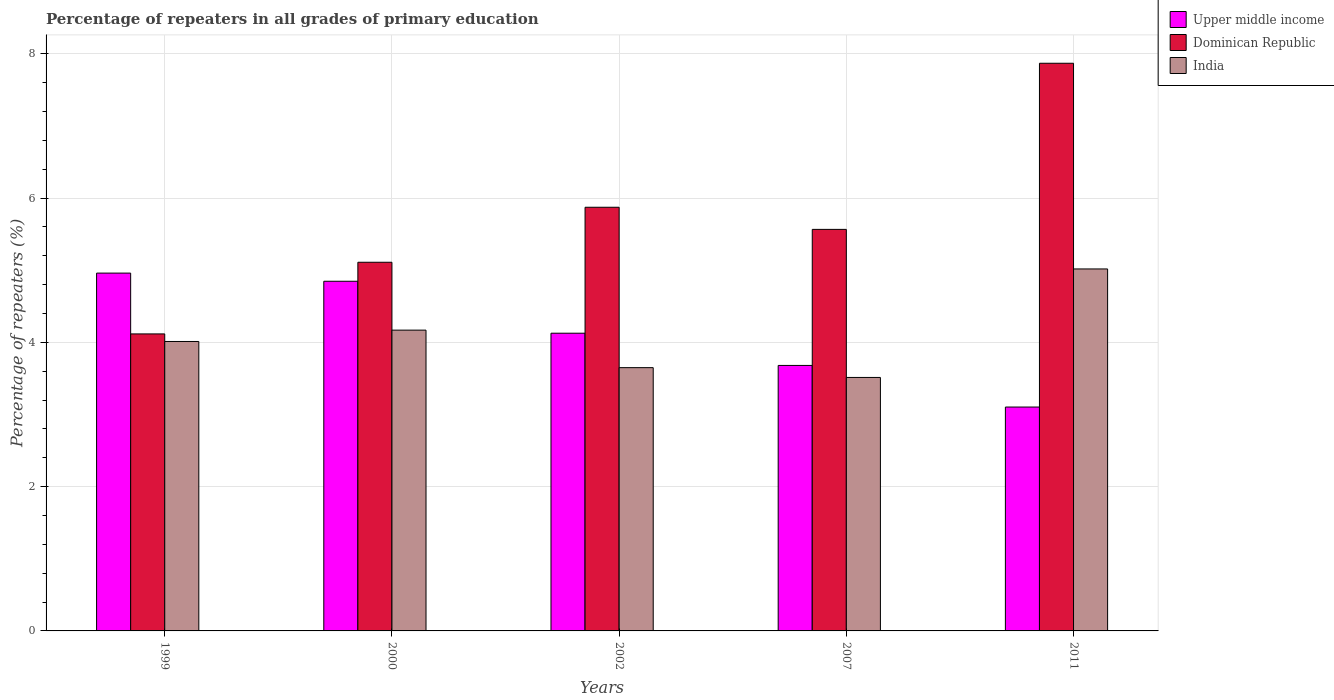How many different coloured bars are there?
Offer a very short reply. 3. Are the number of bars per tick equal to the number of legend labels?
Provide a short and direct response. Yes. How many bars are there on the 1st tick from the left?
Give a very brief answer. 3. How many bars are there on the 4th tick from the right?
Your response must be concise. 3. What is the label of the 3rd group of bars from the left?
Provide a succinct answer. 2002. What is the percentage of repeaters in Dominican Republic in 2011?
Your response must be concise. 7.87. Across all years, what is the maximum percentage of repeaters in India?
Keep it short and to the point. 5.02. Across all years, what is the minimum percentage of repeaters in Dominican Republic?
Your response must be concise. 4.12. What is the total percentage of repeaters in India in the graph?
Provide a short and direct response. 20.36. What is the difference between the percentage of repeaters in Upper middle income in 2000 and that in 2002?
Make the answer very short. 0.72. What is the difference between the percentage of repeaters in Dominican Republic in 2011 and the percentage of repeaters in India in 2007?
Offer a terse response. 4.35. What is the average percentage of repeaters in India per year?
Your response must be concise. 4.07. In the year 2000, what is the difference between the percentage of repeaters in Dominican Republic and percentage of repeaters in Upper middle income?
Ensure brevity in your answer.  0.26. What is the ratio of the percentage of repeaters in Dominican Republic in 2002 to that in 2007?
Provide a short and direct response. 1.06. What is the difference between the highest and the second highest percentage of repeaters in Dominican Republic?
Keep it short and to the point. 2. What is the difference between the highest and the lowest percentage of repeaters in Dominican Republic?
Offer a very short reply. 3.75. In how many years, is the percentage of repeaters in Dominican Republic greater than the average percentage of repeaters in Dominican Republic taken over all years?
Your answer should be compact. 2. Is the sum of the percentage of repeaters in India in 1999 and 2000 greater than the maximum percentage of repeaters in Upper middle income across all years?
Your response must be concise. Yes. What does the 1st bar from the right in 2002 represents?
Give a very brief answer. India. How many years are there in the graph?
Provide a short and direct response. 5. What is the difference between two consecutive major ticks on the Y-axis?
Your response must be concise. 2. Are the values on the major ticks of Y-axis written in scientific E-notation?
Offer a terse response. No. Does the graph contain any zero values?
Ensure brevity in your answer.  No. Where does the legend appear in the graph?
Your response must be concise. Top right. What is the title of the graph?
Offer a very short reply. Percentage of repeaters in all grades of primary education. What is the label or title of the Y-axis?
Offer a very short reply. Percentage of repeaters (%). What is the Percentage of repeaters (%) of Upper middle income in 1999?
Offer a terse response. 4.96. What is the Percentage of repeaters (%) of Dominican Republic in 1999?
Offer a terse response. 4.12. What is the Percentage of repeaters (%) of India in 1999?
Make the answer very short. 4.01. What is the Percentage of repeaters (%) in Upper middle income in 2000?
Your answer should be compact. 4.85. What is the Percentage of repeaters (%) in Dominican Republic in 2000?
Give a very brief answer. 5.11. What is the Percentage of repeaters (%) in India in 2000?
Ensure brevity in your answer.  4.17. What is the Percentage of repeaters (%) of Upper middle income in 2002?
Your response must be concise. 4.13. What is the Percentage of repeaters (%) of Dominican Republic in 2002?
Offer a very short reply. 5.87. What is the Percentage of repeaters (%) in India in 2002?
Your response must be concise. 3.65. What is the Percentage of repeaters (%) in Upper middle income in 2007?
Give a very brief answer. 3.68. What is the Percentage of repeaters (%) of Dominican Republic in 2007?
Your answer should be very brief. 5.57. What is the Percentage of repeaters (%) of India in 2007?
Provide a short and direct response. 3.51. What is the Percentage of repeaters (%) of Upper middle income in 2011?
Give a very brief answer. 3.1. What is the Percentage of repeaters (%) in Dominican Republic in 2011?
Provide a short and direct response. 7.87. What is the Percentage of repeaters (%) in India in 2011?
Offer a terse response. 5.02. Across all years, what is the maximum Percentage of repeaters (%) of Upper middle income?
Offer a terse response. 4.96. Across all years, what is the maximum Percentage of repeaters (%) of Dominican Republic?
Provide a short and direct response. 7.87. Across all years, what is the maximum Percentage of repeaters (%) in India?
Provide a succinct answer. 5.02. Across all years, what is the minimum Percentage of repeaters (%) in Upper middle income?
Your answer should be very brief. 3.1. Across all years, what is the minimum Percentage of repeaters (%) of Dominican Republic?
Your response must be concise. 4.12. Across all years, what is the minimum Percentage of repeaters (%) in India?
Your answer should be very brief. 3.51. What is the total Percentage of repeaters (%) of Upper middle income in the graph?
Your answer should be compact. 20.72. What is the total Percentage of repeaters (%) in Dominican Republic in the graph?
Offer a terse response. 28.53. What is the total Percentage of repeaters (%) of India in the graph?
Offer a very short reply. 20.36. What is the difference between the Percentage of repeaters (%) of Upper middle income in 1999 and that in 2000?
Provide a short and direct response. 0.11. What is the difference between the Percentage of repeaters (%) of Dominican Republic in 1999 and that in 2000?
Ensure brevity in your answer.  -0.99. What is the difference between the Percentage of repeaters (%) in India in 1999 and that in 2000?
Your response must be concise. -0.16. What is the difference between the Percentage of repeaters (%) of Upper middle income in 1999 and that in 2002?
Keep it short and to the point. 0.83. What is the difference between the Percentage of repeaters (%) in Dominican Republic in 1999 and that in 2002?
Your answer should be compact. -1.76. What is the difference between the Percentage of repeaters (%) in India in 1999 and that in 2002?
Offer a very short reply. 0.36. What is the difference between the Percentage of repeaters (%) in Upper middle income in 1999 and that in 2007?
Provide a succinct answer. 1.28. What is the difference between the Percentage of repeaters (%) in Dominican Republic in 1999 and that in 2007?
Keep it short and to the point. -1.45. What is the difference between the Percentage of repeaters (%) in India in 1999 and that in 2007?
Offer a terse response. 0.5. What is the difference between the Percentage of repeaters (%) of Upper middle income in 1999 and that in 2011?
Your answer should be compact. 1.86. What is the difference between the Percentage of repeaters (%) in Dominican Republic in 1999 and that in 2011?
Provide a short and direct response. -3.75. What is the difference between the Percentage of repeaters (%) of India in 1999 and that in 2011?
Give a very brief answer. -1.01. What is the difference between the Percentage of repeaters (%) in Upper middle income in 2000 and that in 2002?
Your response must be concise. 0.72. What is the difference between the Percentage of repeaters (%) in Dominican Republic in 2000 and that in 2002?
Give a very brief answer. -0.76. What is the difference between the Percentage of repeaters (%) of India in 2000 and that in 2002?
Your response must be concise. 0.52. What is the difference between the Percentage of repeaters (%) of Dominican Republic in 2000 and that in 2007?
Your answer should be very brief. -0.46. What is the difference between the Percentage of repeaters (%) of India in 2000 and that in 2007?
Ensure brevity in your answer.  0.66. What is the difference between the Percentage of repeaters (%) of Upper middle income in 2000 and that in 2011?
Give a very brief answer. 1.74. What is the difference between the Percentage of repeaters (%) of Dominican Republic in 2000 and that in 2011?
Your answer should be compact. -2.76. What is the difference between the Percentage of repeaters (%) of India in 2000 and that in 2011?
Keep it short and to the point. -0.85. What is the difference between the Percentage of repeaters (%) of Upper middle income in 2002 and that in 2007?
Your answer should be compact. 0.45. What is the difference between the Percentage of repeaters (%) of Dominican Republic in 2002 and that in 2007?
Offer a very short reply. 0.31. What is the difference between the Percentage of repeaters (%) in India in 2002 and that in 2007?
Give a very brief answer. 0.14. What is the difference between the Percentage of repeaters (%) of Upper middle income in 2002 and that in 2011?
Offer a terse response. 1.02. What is the difference between the Percentage of repeaters (%) in Dominican Republic in 2002 and that in 2011?
Your answer should be very brief. -2. What is the difference between the Percentage of repeaters (%) of India in 2002 and that in 2011?
Your response must be concise. -1.37. What is the difference between the Percentage of repeaters (%) in Upper middle income in 2007 and that in 2011?
Your answer should be very brief. 0.58. What is the difference between the Percentage of repeaters (%) of Dominican Republic in 2007 and that in 2011?
Offer a terse response. -2.3. What is the difference between the Percentage of repeaters (%) in India in 2007 and that in 2011?
Offer a terse response. -1.5. What is the difference between the Percentage of repeaters (%) of Upper middle income in 1999 and the Percentage of repeaters (%) of Dominican Republic in 2000?
Ensure brevity in your answer.  -0.15. What is the difference between the Percentage of repeaters (%) in Upper middle income in 1999 and the Percentage of repeaters (%) in India in 2000?
Offer a very short reply. 0.79. What is the difference between the Percentage of repeaters (%) in Dominican Republic in 1999 and the Percentage of repeaters (%) in India in 2000?
Provide a short and direct response. -0.05. What is the difference between the Percentage of repeaters (%) of Upper middle income in 1999 and the Percentage of repeaters (%) of Dominican Republic in 2002?
Offer a terse response. -0.91. What is the difference between the Percentage of repeaters (%) of Upper middle income in 1999 and the Percentage of repeaters (%) of India in 2002?
Keep it short and to the point. 1.31. What is the difference between the Percentage of repeaters (%) in Dominican Republic in 1999 and the Percentage of repeaters (%) in India in 2002?
Give a very brief answer. 0.47. What is the difference between the Percentage of repeaters (%) in Upper middle income in 1999 and the Percentage of repeaters (%) in Dominican Republic in 2007?
Offer a terse response. -0.61. What is the difference between the Percentage of repeaters (%) of Upper middle income in 1999 and the Percentage of repeaters (%) of India in 2007?
Provide a short and direct response. 1.45. What is the difference between the Percentage of repeaters (%) of Dominican Republic in 1999 and the Percentage of repeaters (%) of India in 2007?
Make the answer very short. 0.6. What is the difference between the Percentage of repeaters (%) of Upper middle income in 1999 and the Percentage of repeaters (%) of Dominican Republic in 2011?
Your answer should be compact. -2.91. What is the difference between the Percentage of repeaters (%) in Upper middle income in 1999 and the Percentage of repeaters (%) in India in 2011?
Your answer should be very brief. -0.06. What is the difference between the Percentage of repeaters (%) in Dominican Republic in 1999 and the Percentage of repeaters (%) in India in 2011?
Provide a succinct answer. -0.9. What is the difference between the Percentage of repeaters (%) of Upper middle income in 2000 and the Percentage of repeaters (%) of Dominican Republic in 2002?
Keep it short and to the point. -1.03. What is the difference between the Percentage of repeaters (%) of Upper middle income in 2000 and the Percentage of repeaters (%) of India in 2002?
Your answer should be compact. 1.2. What is the difference between the Percentage of repeaters (%) of Dominican Republic in 2000 and the Percentage of repeaters (%) of India in 2002?
Your response must be concise. 1.46. What is the difference between the Percentage of repeaters (%) in Upper middle income in 2000 and the Percentage of repeaters (%) in Dominican Republic in 2007?
Keep it short and to the point. -0.72. What is the difference between the Percentage of repeaters (%) in Upper middle income in 2000 and the Percentage of repeaters (%) in India in 2007?
Your answer should be very brief. 1.33. What is the difference between the Percentage of repeaters (%) in Dominican Republic in 2000 and the Percentage of repeaters (%) in India in 2007?
Ensure brevity in your answer.  1.6. What is the difference between the Percentage of repeaters (%) in Upper middle income in 2000 and the Percentage of repeaters (%) in Dominican Republic in 2011?
Make the answer very short. -3.02. What is the difference between the Percentage of repeaters (%) in Upper middle income in 2000 and the Percentage of repeaters (%) in India in 2011?
Provide a succinct answer. -0.17. What is the difference between the Percentage of repeaters (%) of Dominican Republic in 2000 and the Percentage of repeaters (%) of India in 2011?
Make the answer very short. 0.09. What is the difference between the Percentage of repeaters (%) in Upper middle income in 2002 and the Percentage of repeaters (%) in Dominican Republic in 2007?
Your answer should be very brief. -1.44. What is the difference between the Percentage of repeaters (%) in Upper middle income in 2002 and the Percentage of repeaters (%) in India in 2007?
Keep it short and to the point. 0.61. What is the difference between the Percentage of repeaters (%) of Dominican Republic in 2002 and the Percentage of repeaters (%) of India in 2007?
Ensure brevity in your answer.  2.36. What is the difference between the Percentage of repeaters (%) of Upper middle income in 2002 and the Percentage of repeaters (%) of Dominican Republic in 2011?
Make the answer very short. -3.74. What is the difference between the Percentage of repeaters (%) of Upper middle income in 2002 and the Percentage of repeaters (%) of India in 2011?
Your response must be concise. -0.89. What is the difference between the Percentage of repeaters (%) in Dominican Republic in 2002 and the Percentage of repeaters (%) in India in 2011?
Keep it short and to the point. 0.85. What is the difference between the Percentage of repeaters (%) in Upper middle income in 2007 and the Percentage of repeaters (%) in Dominican Republic in 2011?
Offer a very short reply. -4.19. What is the difference between the Percentage of repeaters (%) of Upper middle income in 2007 and the Percentage of repeaters (%) of India in 2011?
Provide a succinct answer. -1.34. What is the difference between the Percentage of repeaters (%) in Dominican Republic in 2007 and the Percentage of repeaters (%) in India in 2011?
Offer a terse response. 0.55. What is the average Percentage of repeaters (%) in Upper middle income per year?
Make the answer very short. 4.14. What is the average Percentage of repeaters (%) of Dominican Republic per year?
Offer a terse response. 5.71. What is the average Percentage of repeaters (%) of India per year?
Ensure brevity in your answer.  4.07. In the year 1999, what is the difference between the Percentage of repeaters (%) of Upper middle income and Percentage of repeaters (%) of Dominican Republic?
Your answer should be very brief. 0.84. In the year 1999, what is the difference between the Percentage of repeaters (%) of Upper middle income and Percentage of repeaters (%) of India?
Your answer should be compact. 0.95. In the year 1999, what is the difference between the Percentage of repeaters (%) in Dominican Republic and Percentage of repeaters (%) in India?
Keep it short and to the point. 0.1. In the year 2000, what is the difference between the Percentage of repeaters (%) of Upper middle income and Percentage of repeaters (%) of Dominican Republic?
Keep it short and to the point. -0.26. In the year 2000, what is the difference between the Percentage of repeaters (%) in Upper middle income and Percentage of repeaters (%) in India?
Keep it short and to the point. 0.68. In the year 2000, what is the difference between the Percentage of repeaters (%) in Dominican Republic and Percentage of repeaters (%) in India?
Your response must be concise. 0.94. In the year 2002, what is the difference between the Percentage of repeaters (%) in Upper middle income and Percentage of repeaters (%) in Dominican Republic?
Your response must be concise. -1.75. In the year 2002, what is the difference between the Percentage of repeaters (%) of Upper middle income and Percentage of repeaters (%) of India?
Make the answer very short. 0.48. In the year 2002, what is the difference between the Percentage of repeaters (%) in Dominican Republic and Percentage of repeaters (%) in India?
Give a very brief answer. 2.22. In the year 2007, what is the difference between the Percentage of repeaters (%) in Upper middle income and Percentage of repeaters (%) in Dominican Republic?
Give a very brief answer. -1.89. In the year 2007, what is the difference between the Percentage of repeaters (%) of Upper middle income and Percentage of repeaters (%) of India?
Ensure brevity in your answer.  0.17. In the year 2007, what is the difference between the Percentage of repeaters (%) of Dominican Republic and Percentage of repeaters (%) of India?
Your response must be concise. 2.05. In the year 2011, what is the difference between the Percentage of repeaters (%) of Upper middle income and Percentage of repeaters (%) of Dominican Republic?
Your response must be concise. -4.77. In the year 2011, what is the difference between the Percentage of repeaters (%) in Upper middle income and Percentage of repeaters (%) in India?
Your response must be concise. -1.91. In the year 2011, what is the difference between the Percentage of repeaters (%) of Dominican Republic and Percentage of repeaters (%) of India?
Offer a terse response. 2.85. What is the ratio of the Percentage of repeaters (%) in Upper middle income in 1999 to that in 2000?
Give a very brief answer. 1.02. What is the ratio of the Percentage of repeaters (%) in Dominican Republic in 1999 to that in 2000?
Your answer should be very brief. 0.81. What is the ratio of the Percentage of repeaters (%) of India in 1999 to that in 2000?
Offer a very short reply. 0.96. What is the ratio of the Percentage of repeaters (%) in Upper middle income in 1999 to that in 2002?
Provide a succinct answer. 1.2. What is the ratio of the Percentage of repeaters (%) of Dominican Republic in 1999 to that in 2002?
Give a very brief answer. 0.7. What is the ratio of the Percentage of repeaters (%) in India in 1999 to that in 2002?
Your response must be concise. 1.1. What is the ratio of the Percentage of repeaters (%) in Upper middle income in 1999 to that in 2007?
Offer a very short reply. 1.35. What is the ratio of the Percentage of repeaters (%) of Dominican Republic in 1999 to that in 2007?
Your answer should be very brief. 0.74. What is the ratio of the Percentage of repeaters (%) in India in 1999 to that in 2007?
Make the answer very short. 1.14. What is the ratio of the Percentage of repeaters (%) of Upper middle income in 1999 to that in 2011?
Offer a very short reply. 1.6. What is the ratio of the Percentage of repeaters (%) of Dominican Republic in 1999 to that in 2011?
Offer a terse response. 0.52. What is the ratio of the Percentage of repeaters (%) of India in 1999 to that in 2011?
Your answer should be compact. 0.8. What is the ratio of the Percentage of repeaters (%) of Upper middle income in 2000 to that in 2002?
Give a very brief answer. 1.17. What is the ratio of the Percentage of repeaters (%) of Dominican Republic in 2000 to that in 2002?
Offer a terse response. 0.87. What is the ratio of the Percentage of repeaters (%) of India in 2000 to that in 2002?
Your response must be concise. 1.14. What is the ratio of the Percentage of repeaters (%) in Upper middle income in 2000 to that in 2007?
Your answer should be compact. 1.32. What is the ratio of the Percentage of repeaters (%) in Dominican Republic in 2000 to that in 2007?
Provide a short and direct response. 0.92. What is the ratio of the Percentage of repeaters (%) in India in 2000 to that in 2007?
Provide a short and direct response. 1.19. What is the ratio of the Percentage of repeaters (%) in Upper middle income in 2000 to that in 2011?
Your answer should be compact. 1.56. What is the ratio of the Percentage of repeaters (%) in Dominican Republic in 2000 to that in 2011?
Make the answer very short. 0.65. What is the ratio of the Percentage of repeaters (%) of India in 2000 to that in 2011?
Give a very brief answer. 0.83. What is the ratio of the Percentage of repeaters (%) in Upper middle income in 2002 to that in 2007?
Provide a short and direct response. 1.12. What is the ratio of the Percentage of repeaters (%) of Dominican Republic in 2002 to that in 2007?
Your response must be concise. 1.06. What is the ratio of the Percentage of repeaters (%) in India in 2002 to that in 2007?
Provide a succinct answer. 1.04. What is the ratio of the Percentage of repeaters (%) of Upper middle income in 2002 to that in 2011?
Your answer should be very brief. 1.33. What is the ratio of the Percentage of repeaters (%) in Dominican Republic in 2002 to that in 2011?
Your response must be concise. 0.75. What is the ratio of the Percentage of repeaters (%) of India in 2002 to that in 2011?
Offer a very short reply. 0.73. What is the ratio of the Percentage of repeaters (%) of Upper middle income in 2007 to that in 2011?
Ensure brevity in your answer.  1.19. What is the ratio of the Percentage of repeaters (%) in Dominican Republic in 2007 to that in 2011?
Provide a succinct answer. 0.71. What is the ratio of the Percentage of repeaters (%) of India in 2007 to that in 2011?
Provide a short and direct response. 0.7. What is the difference between the highest and the second highest Percentage of repeaters (%) in Upper middle income?
Your answer should be compact. 0.11. What is the difference between the highest and the second highest Percentage of repeaters (%) in Dominican Republic?
Give a very brief answer. 2. What is the difference between the highest and the second highest Percentage of repeaters (%) of India?
Give a very brief answer. 0.85. What is the difference between the highest and the lowest Percentage of repeaters (%) of Upper middle income?
Your answer should be very brief. 1.86. What is the difference between the highest and the lowest Percentage of repeaters (%) of Dominican Republic?
Provide a short and direct response. 3.75. What is the difference between the highest and the lowest Percentage of repeaters (%) in India?
Your answer should be very brief. 1.5. 